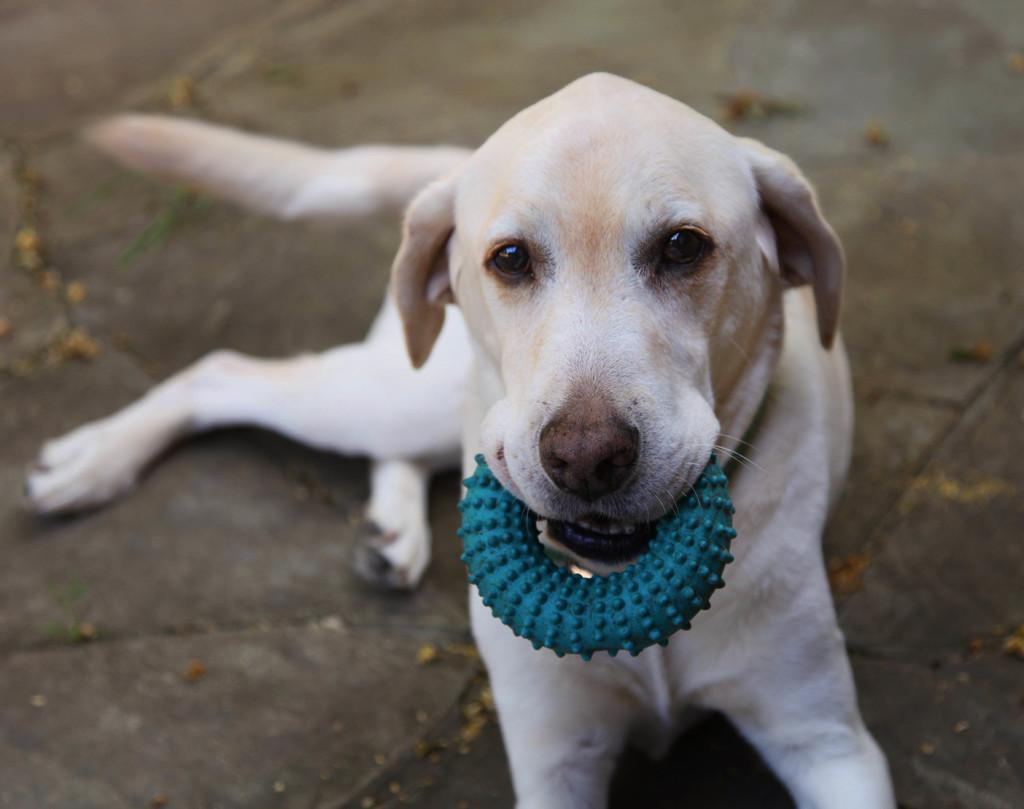What type of animal is in the image? There is a dog in the image. What is the dog doing in the image? The dog is sitting on the ground. Is there anything on the dog's neck? Yes, there is an object on the dog's neck. What color is the object on the dog's neck? The object is green in color. How does the dog serve its master in the image? The image does not depict the dog serving its master; it only shows the dog sitting on the ground with a green object on its neck. 